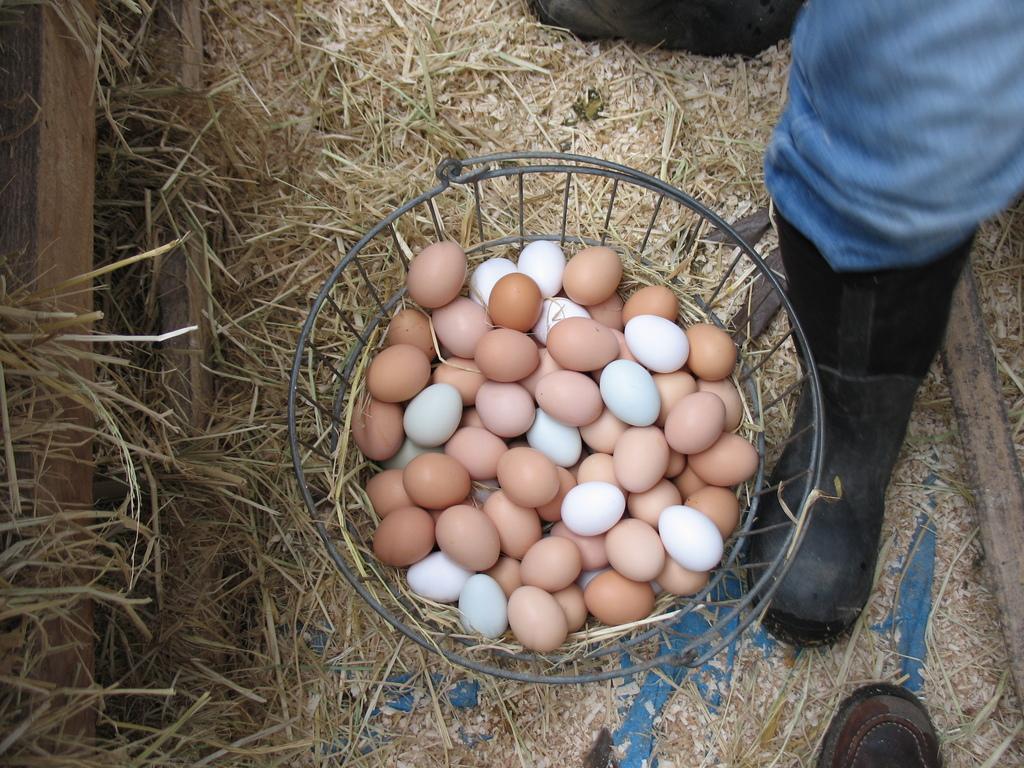Could you give a brief overview of what you see in this image? In this image I can see the eggs in the basket. In the background, I can see the grass. 